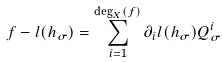Convert formula to latex. <formula><loc_0><loc_0><loc_500><loc_500>f - l ( h _ { \sigma } ) = \sum _ { i = 1 } ^ { \deg _ { X } ( f ) } \partial _ { i } l ( h _ { \sigma } ) Q _ { \sigma } ^ { i }</formula> 